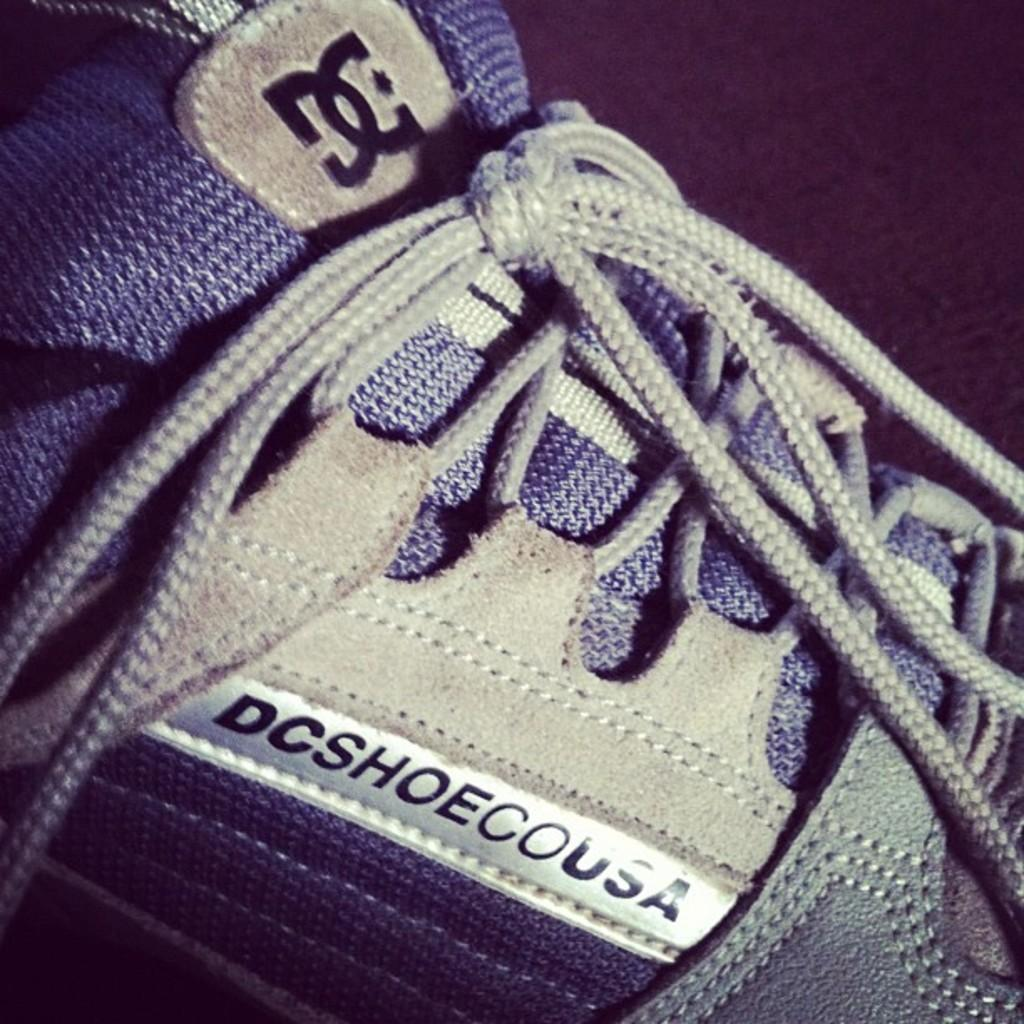What object is located in the front of the image? There is a shoe in the front of the image. How far away is the apparel from the shoe in the image? There is no apparel mentioned in the image, only a shoe. The shoe is the only object mentioned in the provided facts. 